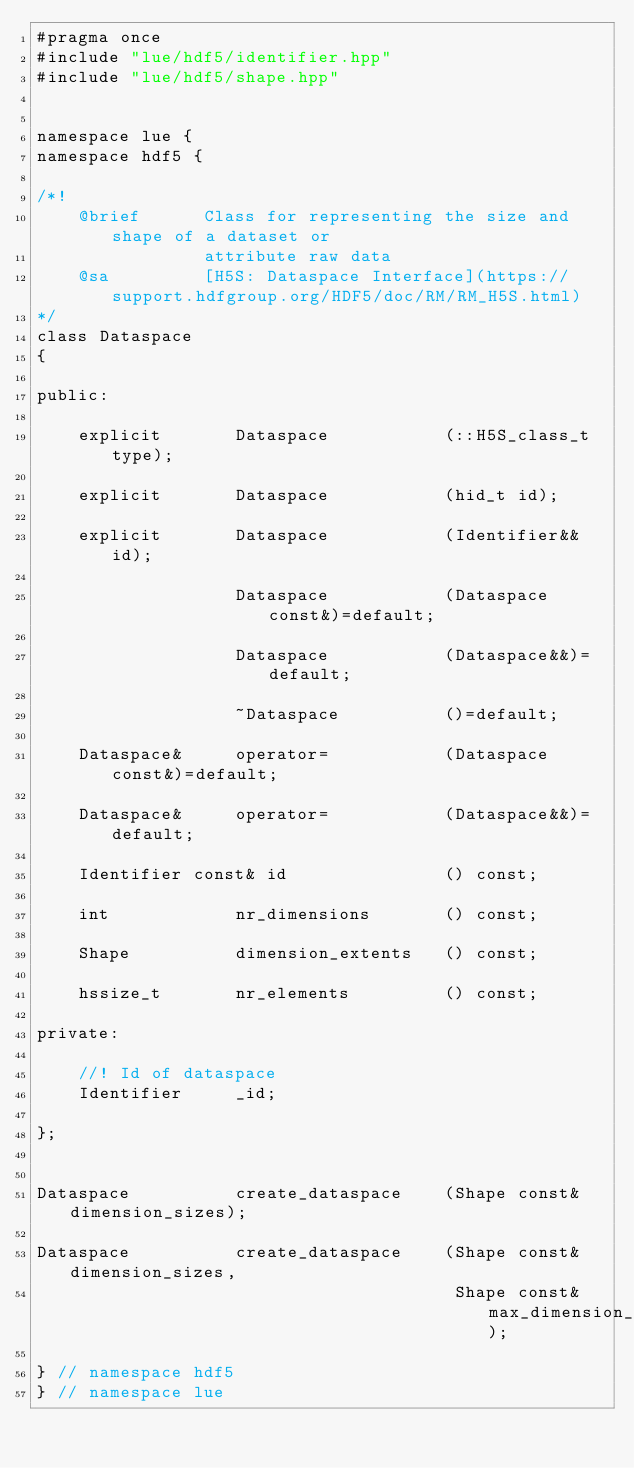Convert code to text. <code><loc_0><loc_0><loc_500><loc_500><_C++_>#pragma once
#include "lue/hdf5/identifier.hpp"
#include "lue/hdf5/shape.hpp"


namespace lue {
namespace hdf5 {

/*!
    @brief      Class for representing the size and shape of a dataset or
                attribute raw data
    @sa         [H5S: Dataspace Interface](https://support.hdfgroup.org/HDF5/doc/RM/RM_H5S.html)
*/
class Dataspace
{

public:

    explicit       Dataspace           (::H5S_class_t type);

    explicit       Dataspace           (hid_t id);

    explicit       Dataspace           (Identifier&& id);

                   Dataspace           (Dataspace const&)=default;

                   Dataspace           (Dataspace&&)=default;

                   ~Dataspace          ()=default;

    Dataspace&     operator=           (Dataspace const&)=default;

    Dataspace&     operator=           (Dataspace&&)=default;

    Identifier const& id               () const;

    int            nr_dimensions       () const;

    Shape          dimension_extents   () const;

    hssize_t       nr_elements         () const;

private:

    //! Id of dataspace
    Identifier     _id;

};


Dataspace          create_dataspace    (Shape const& dimension_sizes);

Dataspace          create_dataspace    (Shape const& dimension_sizes,
                                        Shape const& max_dimension_sizes);

} // namespace hdf5
} // namespace lue
</code> 